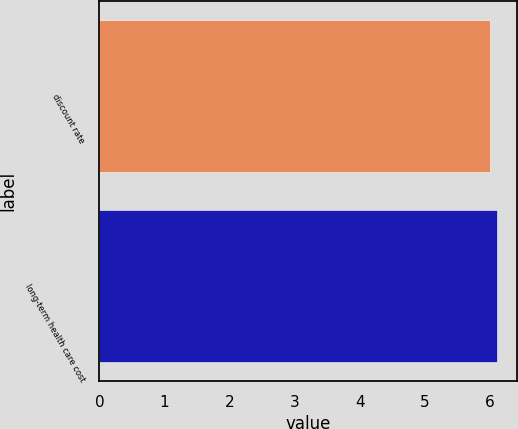Convert chart. <chart><loc_0><loc_0><loc_500><loc_500><bar_chart><fcel>discount rate<fcel>long-term health care cost<nl><fcel>6<fcel>6.1<nl></chart> 